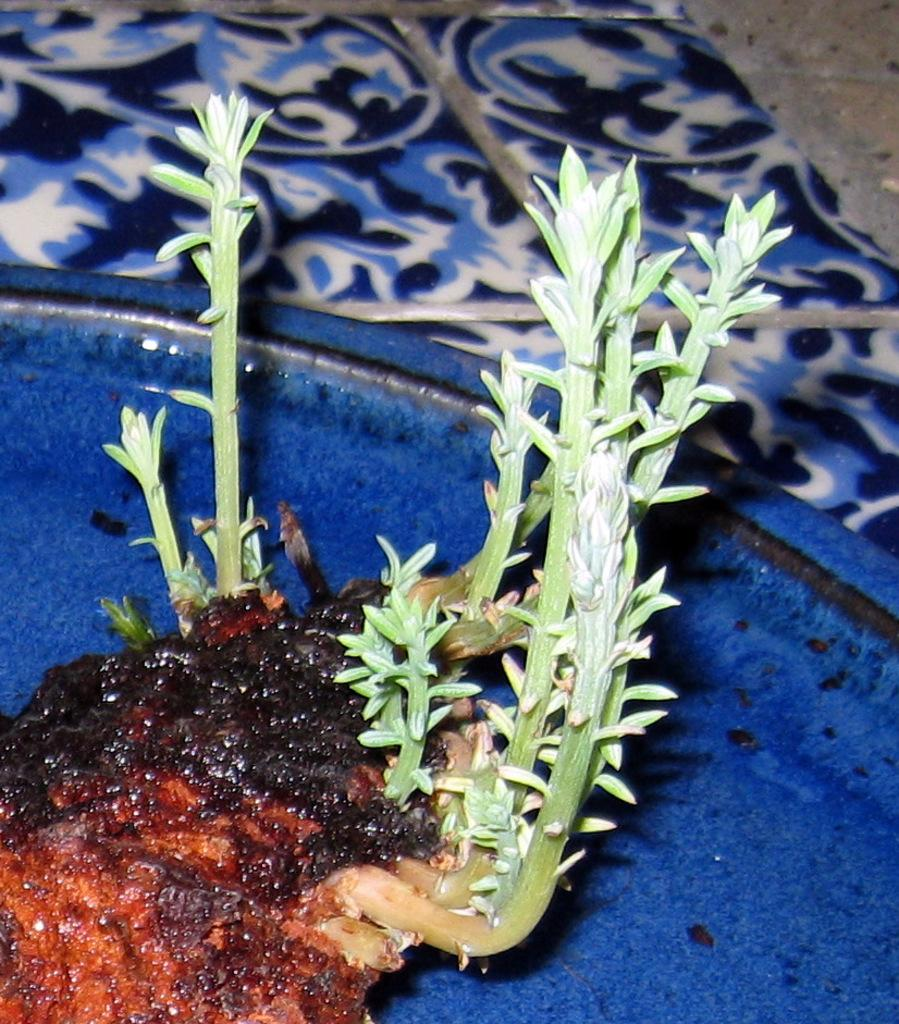What type of living organisms are in the image? There are plants in the image. How are the plants arranged or contained in the image? The plants are in a blue tray. Where is the blue tray located in the image? The blue tray is placed on a platform. Who is the owner of the vest in the image? A: There is no vest present in the image. 